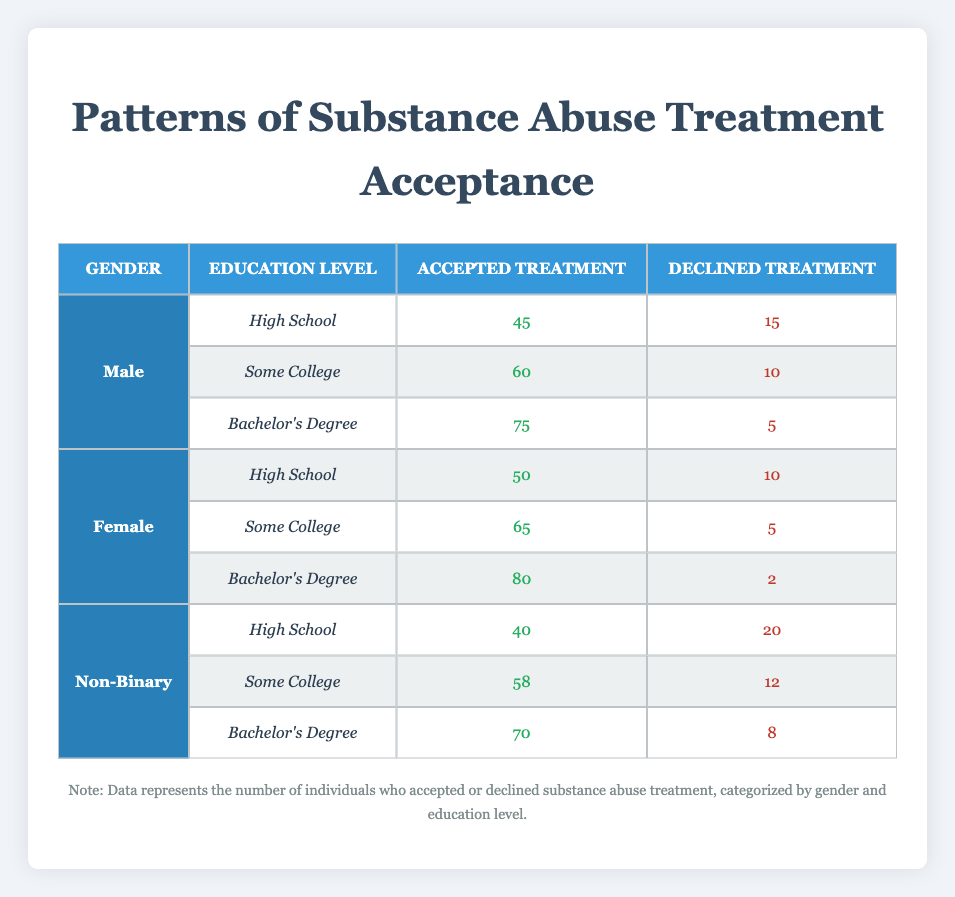What is the total number of individuals who accepted treatment across all education levels for males? To find this, we look at the accepted treatment values for males: 45 (High School) + 60 (Some College) + 75 (Bachelor's Degree) = 180.
Answer: 180 How many females declined treatment at the Bachelor's Degree level? The table shows that for females with a Bachelor's Degree, the declined treatment number is 2.
Answer: 2 What is the average number of males who accepted treatment across all education levels? To find the average, we sum the accepted treatment for males (45 + 60 + 75 = 180) and divide by the number of education levels (3). Therefore, the average is 180/3 = 60.
Answer: 60 Is it true that more non-binary individuals accepted treatment than males at the High School level? For non-binary individuals at the High School level, 40 accepted treatment, whereas 45 males accepted it. Thus, it is not true that non-binary individuals accepted treatment more at this level.
Answer: No What percentage of female individuals with a Bachelor’s Degree accepted treatment? For females with a Bachelor’s Degree, 80 accepted treatment out of a combined total of 80 accepted and 2 declined, leading to a percentage calculation of (80 / (80 + 2)) * 100 = 97.56%. Thus, approximately 98% accepted treatment.
Answer: 98% At which education level did non-binary individuals have the highest acceptance of treatment? By inspecting non-binary individuals, we see the highest acceptance at the Bachelor's Degree level with 70 accepted treatments, compared to 40 and 58 for High School and Some College respectively.
Answer: Bachelor's Degree What is the difference between accepted treatment numbers for males and females with Some College education? Males accepted treatment 60 times while females accepted treatment 65 times. The difference is 65 - 60 = 5, indicating more females accepted treatment at this level.
Answer: 5 Which gender had the highest total accepted treatment across all education levels? Adding accepted treatment numbers: Males 180, Females 195, and Non-Binary 168. Females have the highest total accepted treatment.
Answer: Females What is the total number of individuals who declined treatment at the High School education level? For High School, the declined treatment numbers are 15 (Male) + 10 (Female) + 20 (Non-Binary) = 45.
Answer: 45 